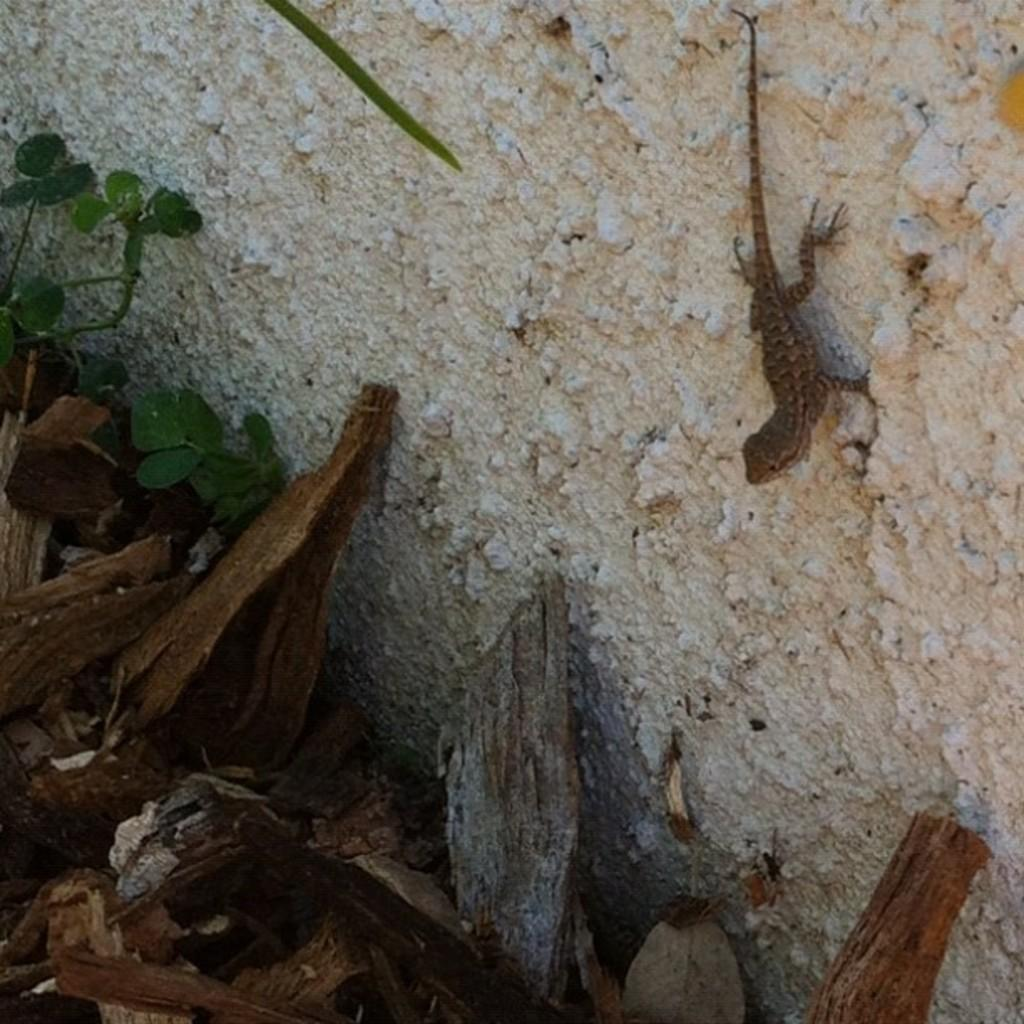What type of animal is on the wall in the image? There is a lizard on the wall in the image. What can be seen at the bottom of the image? There are logs at the bottom of the image. What type of vegetation is present in the image? There is a plant in the image. What type of drum is being played by the partner in the image? There is no partner or drum present in the image. 